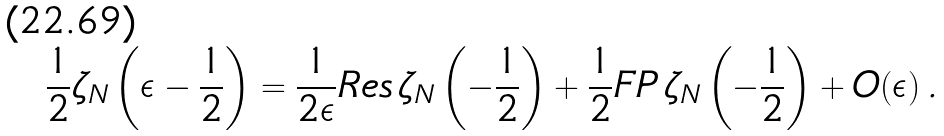Convert formula to latex. <formula><loc_0><loc_0><loc_500><loc_500>\frac { 1 } { 2 } \zeta _ { N } \left ( \epsilon - \frac { 1 } { 2 } \right ) = \frac { 1 } { 2 \epsilon } R e s \, \zeta _ { N } \left ( - \frac { 1 } { 2 } \right ) + \frac { 1 } { 2 } F P \, \zeta _ { N } \left ( - \frac { 1 } { 2 } \right ) + O ( \epsilon ) \, .</formula> 